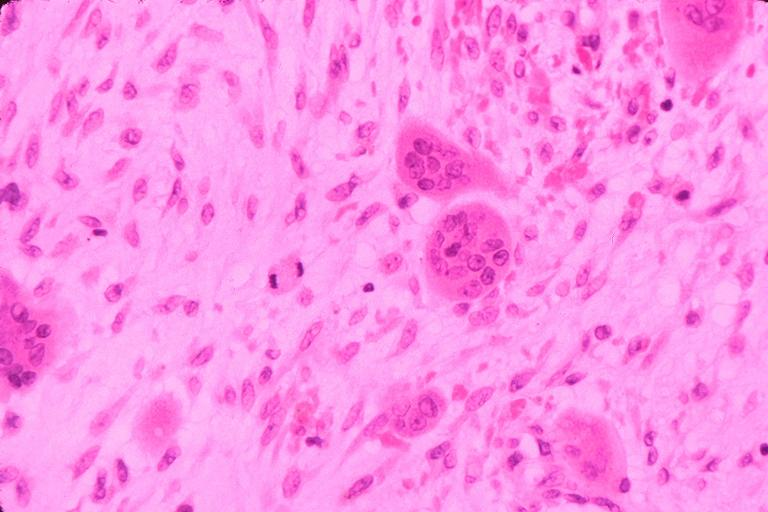s oral present?
Answer the question using a single word or phrase. Yes 